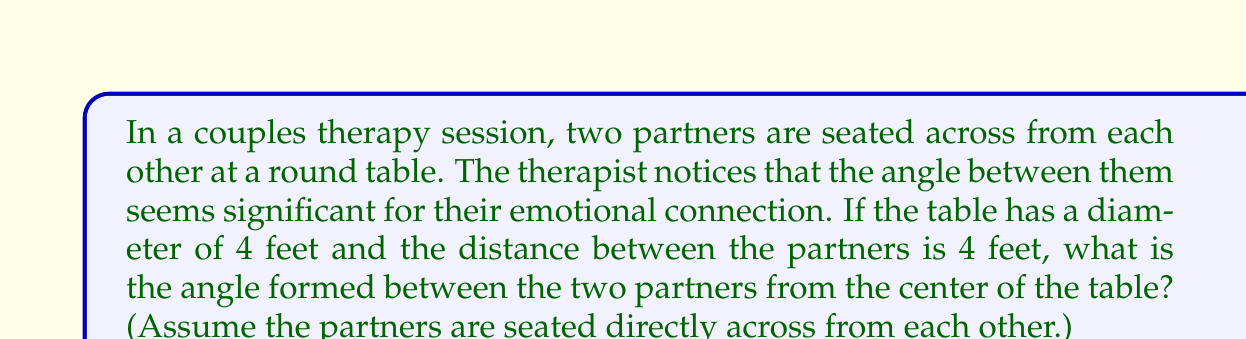Help me with this question. Let's approach this step-by-step, focusing on the geometric relationship rather than overanalyzing its impact on the couple's dynamics:

1) First, we need to visualize the situation. The round table forms a circle, and the two partners form a chord of this circle.

2) The key here is to recognize that we have an isosceles triangle. The two radii from the center of the table to each partner are equal (both are the radius of the table), and we're given the length of the chord (distance between partners).

3) Let's draw this out:

[asy]
unitsize(1cm);
pair A = (2,0);
pair B = (-2,0);
pair O = (0,0);
draw(circle(O,2));
draw(A--B);
draw(O--A);
draw(O--B);
label("A", A, SE);
label("B", B, SW);
label("O", O, N);
label("2", (O--A)/2, NE);
label("2", (O--B)/2, NW);
label("4", (A--B)/2, S);
label("θ", O, S);
[/asy]

4) In this isosceles triangle, we want to find the angle at the center, let's call it $\theta$.

5) We can split this isosceles triangle into two right triangles. Let's focus on one of these right triangles.

6) In this right triangle, we know:
   - The hypotenuse (radius of the table) = 2 feet
   - Half of the chord length = 2 feet

7) We can use the cosine function to find half of our angle:

   $\cos(\frac{\theta}{2}) = \frac{\text{adjacent}}{\text{hypotenuse}} = \frac{2}{2} = 1$

8) Taking the inverse cosine (arccos) of both sides:

   $\frac{\theta}{2} = \arccos(1) = 0$

9) Therefore, $\theta = 2 * 0 = 0$ radians

10) Converting to degrees: $0$ radians = $0$ degrees

This result might seem counterintuitive, but it actually makes sense geometrically. If the distance between the partners is equal to the diameter of the table, they must be sitting at opposite ends of a straight line passing through the center, forming a 180° angle.
Answer: $180°$ 